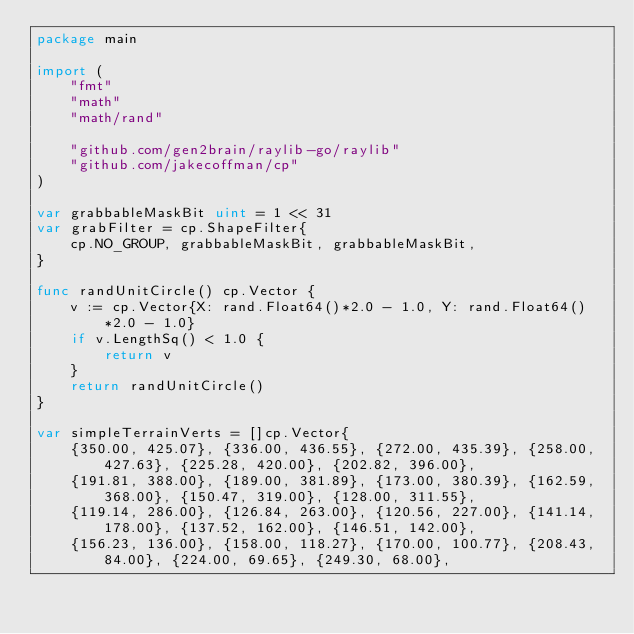<code> <loc_0><loc_0><loc_500><loc_500><_Go_>package main

import (
	"fmt"
	"math"
	"math/rand"

	"github.com/gen2brain/raylib-go/raylib"
	"github.com/jakecoffman/cp"
)

var grabbableMaskBit uint = 1 << 31
var grabFilter = cp.ShapeFilter{
	cp.NO_GROUP, grabbableMaskBit, grabbableMaskBit,
}

func randUnitCircle() cp.Vector {
	v := cp.Vector{X: rand.Float64()*2.0 - 1.0, Y: rand.Float64()*2.0 - 1.0}
	if v.LengthSq() < 1.0 {
		return v
	}
	return randUnitCircle()
}

var simpleTerrainVerts = []cp.Vector{
	{350.00, 425.07}, {336.00, 436.55}, {272.00, 435.39}, {258.00, 427.63}, {225.28, 420.00}, {202.82, 396.00},
	{191.81, 388.00}, {189.00, 381.89}, {173.00, 380.39}, {162.59, 368.00}, {150.47, 319.00}, {128.00, 311.55},
	{119.14, 286.00}, {126.84, 263.00}, {120.56, 227.00}, {141.14, 178.00}, {137.52, 162.00}, {146.51, 142.00},
	{156.23, 136.00}, {158.00, 118.27}, {170.00, 100.77}, {208.43, 84.00}, {224.00, 69.65}, {249.30, 68.00},</code> 